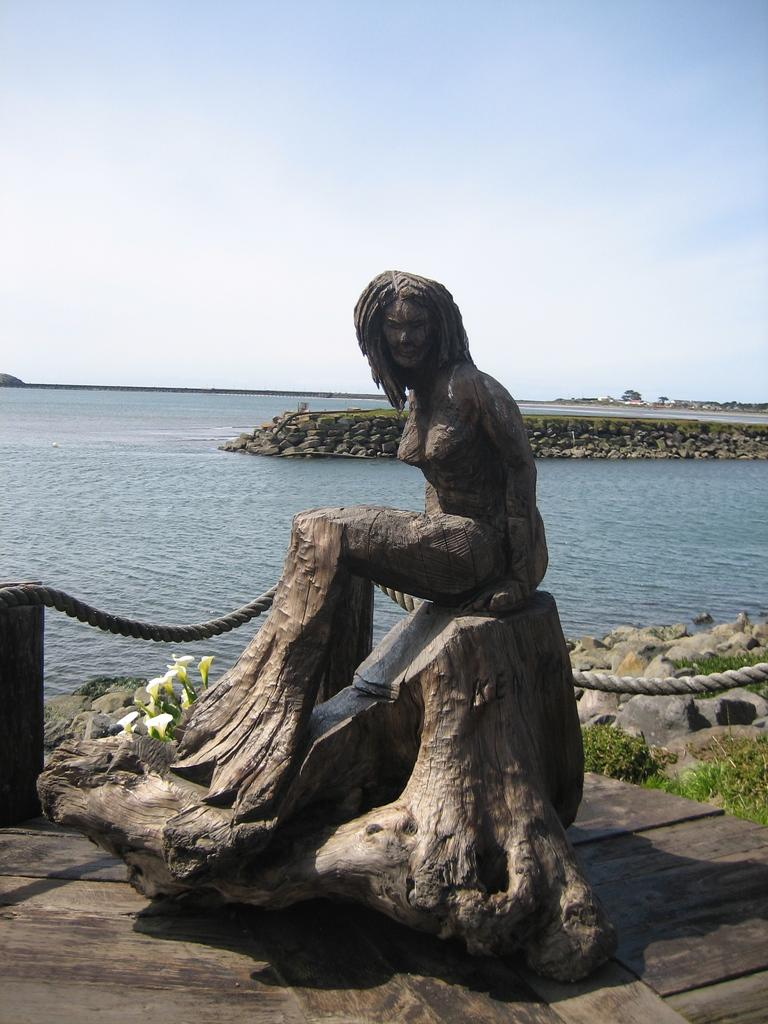What type of object can be seen in the image that is made of wood? There is a wooden carved statue in the image. What type of vegetation is present in the image? There are plants and flowers in the image. What can be seen in the image that is used for containing water? There is water visible in the image. What type of barrier is present in the image? There is a rope fence in the image. What is the condition of the sky in the image? The sky is cloudy in the image. How many passengers are visible in the image? There are no passengers present in the image. What type of mark can be seen on the wooden statue in the image? There is no mark visible on the wooden statue in the image. 